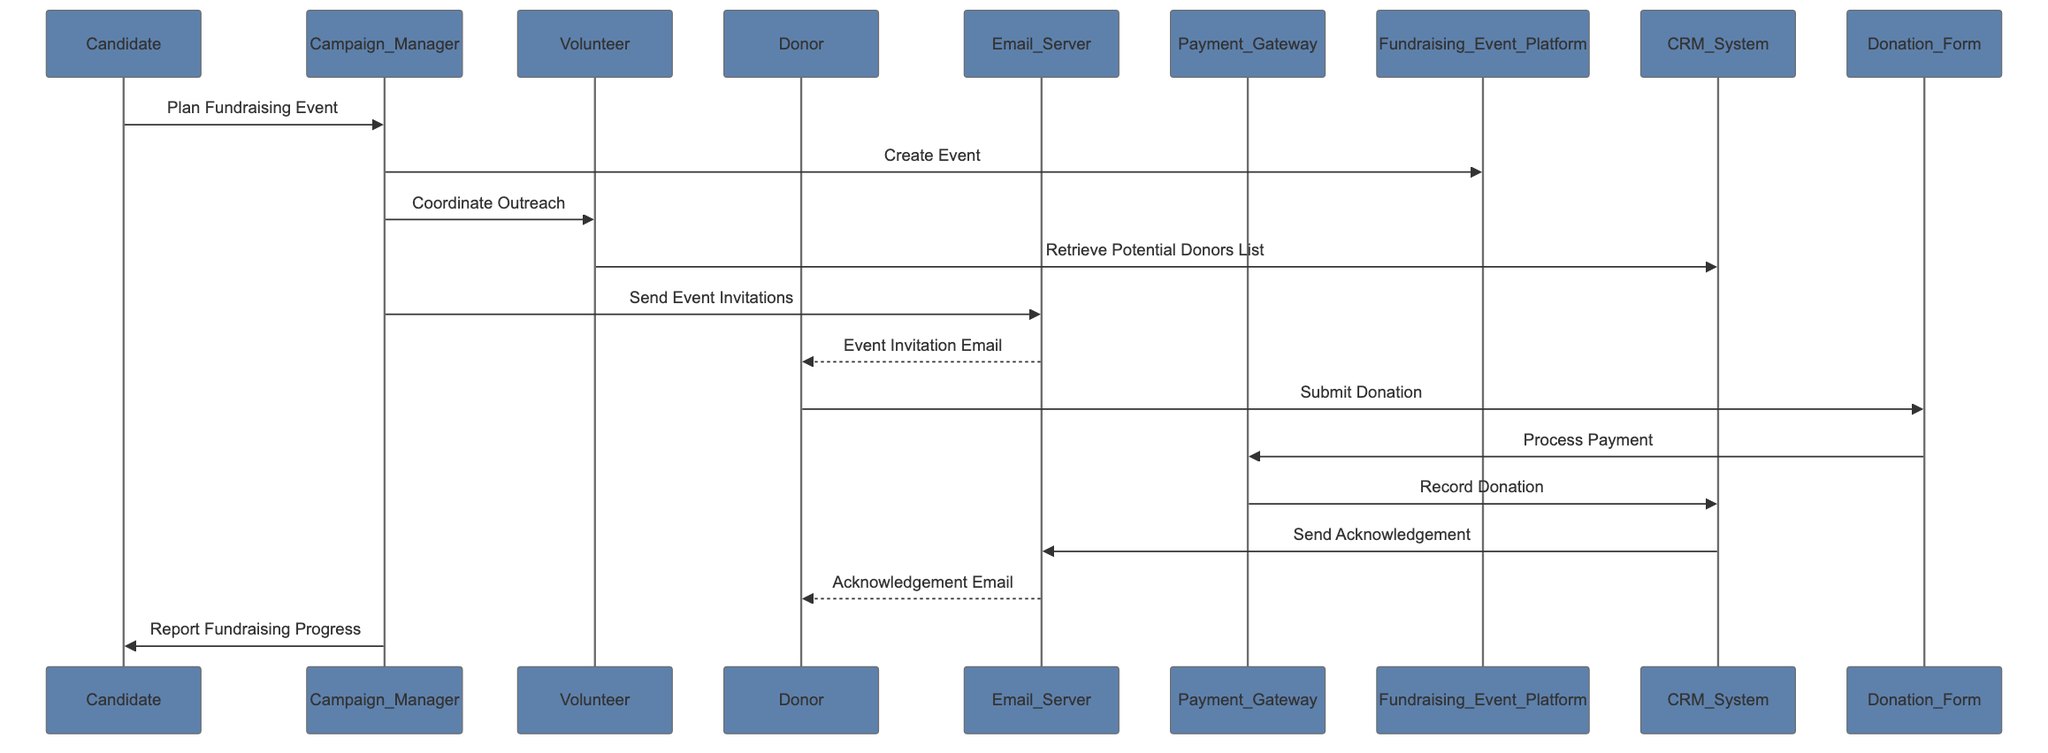What is the first action in the sequence? The first action is initiated by the Candidate, who plans the fundraising event by communicating this to the Campaign Manager.
Answer: Plan Fundraising Event Who sends the event invitations? The Campaign Manager is responsible for sending the event invitations, utilizing the Email Server in this process as indicated in the diagram.
Answer: Campaign_Manager How many actors are involved in the diagram? By counting all distinct participants listed, there are six actors involved in the sequence diagram, which include Candidate, Campaign_Manager, Volunteer, Donor, Email_Server, and Payment_Gateway.
Answer: Six What is the last action performed in the sequence? The last action involves the Email Server sending the Acknowledgement Email to the Donor, completing the donation process.
Answer: Receive Acknowledgement Email Who processes the payment? The Payment Gateway is responsible for processing the payment after the Donor submits their donation through the Donation Form.
Answer: Payment_Gateway Which actor receives the acknowledgment email? The Donor is the recipient of the Acknowledgement Email, which is sent from the Email Server after the donation is recorded in the CRM System.
Answer: Donor What does the Volunteer retrieve from the CRM System? The Volunteer retrieves the list of potential donors from the CRM System to assist in coordinating outreach efforts for the fundraising event.
Answer: Potential Donors List What platform is used to create the fundraising event? The Campaign Manager communicates with the Fundraising Event Platform to create the event after their planning phase with the Candidate.
Answer: Fundraising_Event_Platform 